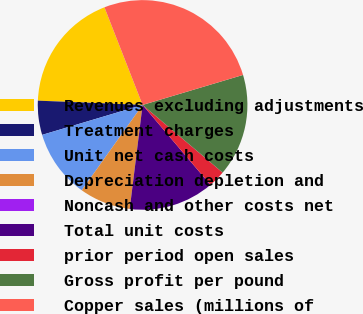Convert chart. <chart><loc_0><loc_0><loc_500><loc_500><pie_chart><fcel>Revenues excluding adjustments<fcel>Treatment charges<fcel>Unit net cash costs<fcel>Depreciation depletion and<fcel>Noncash and other costs net<fcel>Total unit costs<fcel>prior period open sales<fcel>Gross profit per pound<fcel>Copper sales (millions of<nl><fcel>18.42%<fcel>5.26%<fcel>10.53%<fcel>7.9%<fcel>0.0%<fcel>13.16%<fcel>2.63%<fcel>15.79%<fcel>26.31%<nl></chart> 